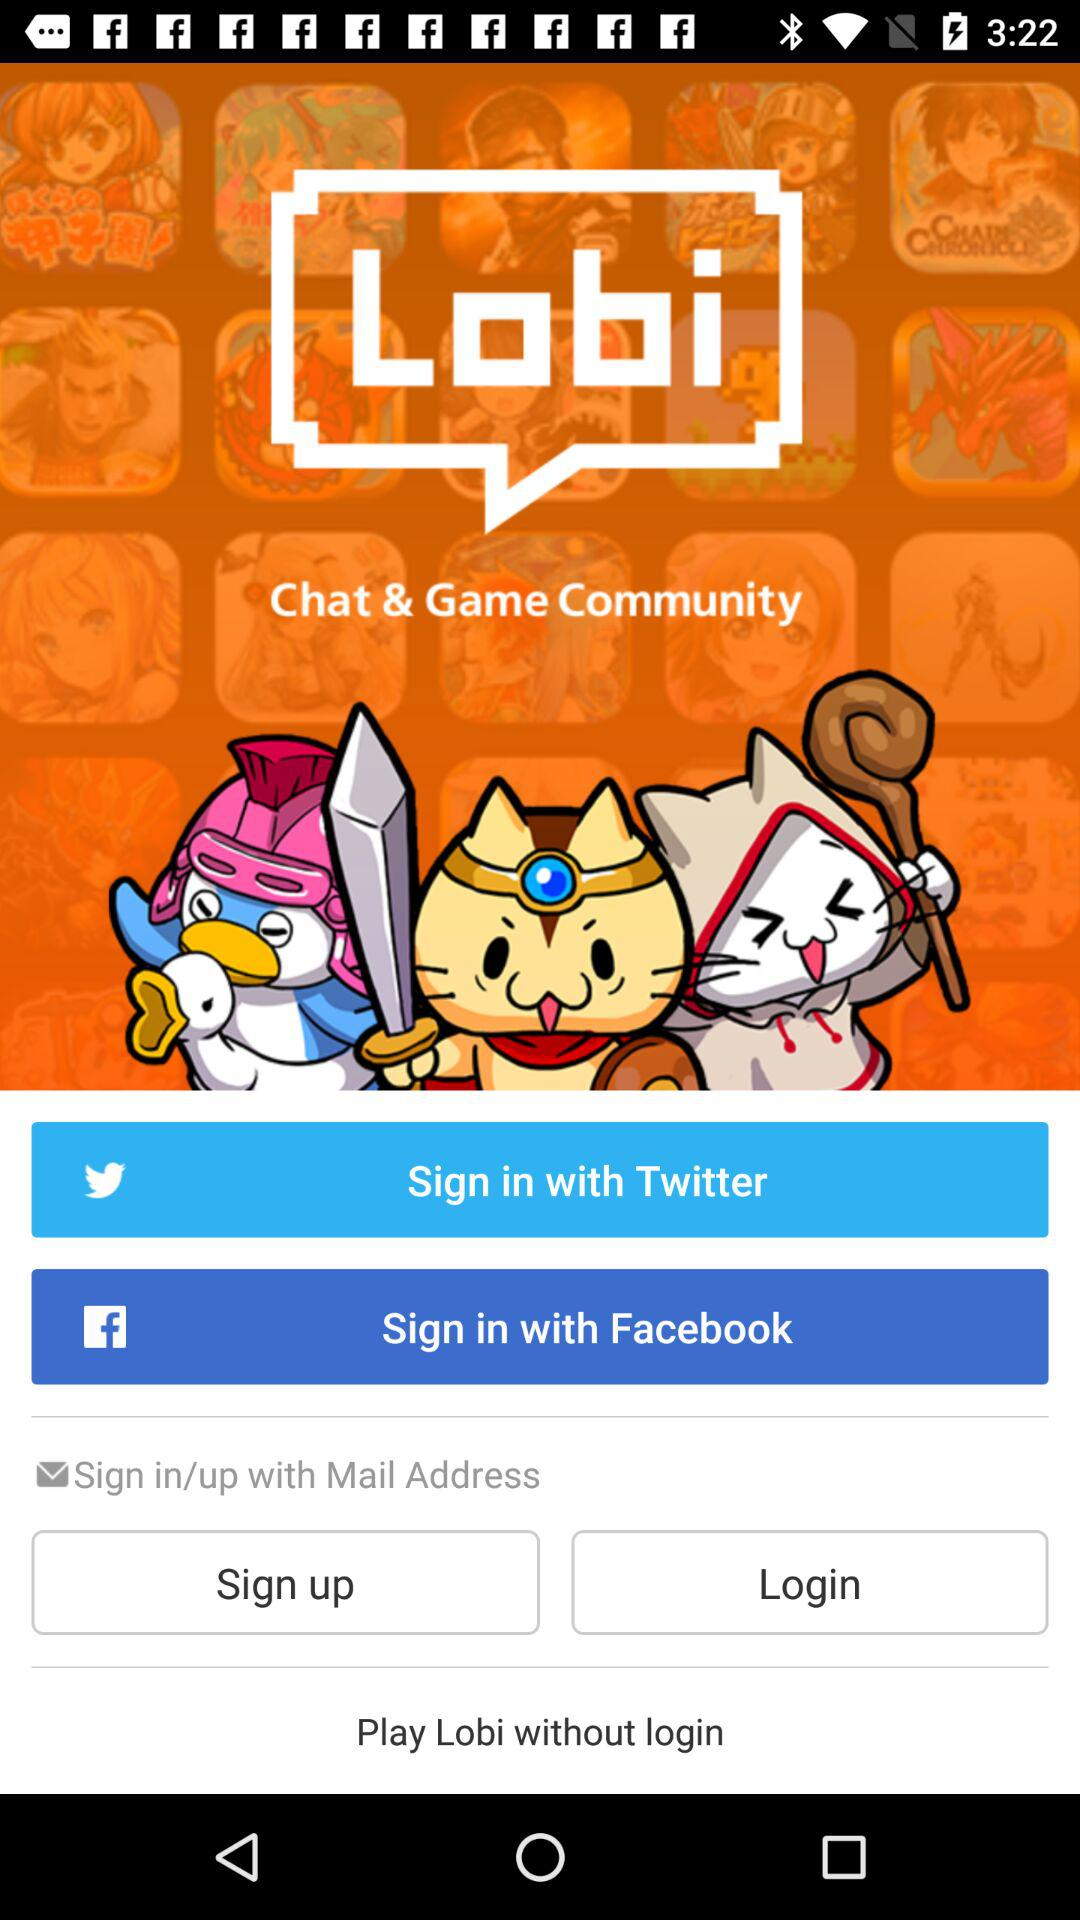How many social media sign in options are there?
Answer the question using a single word or phrase. 2 